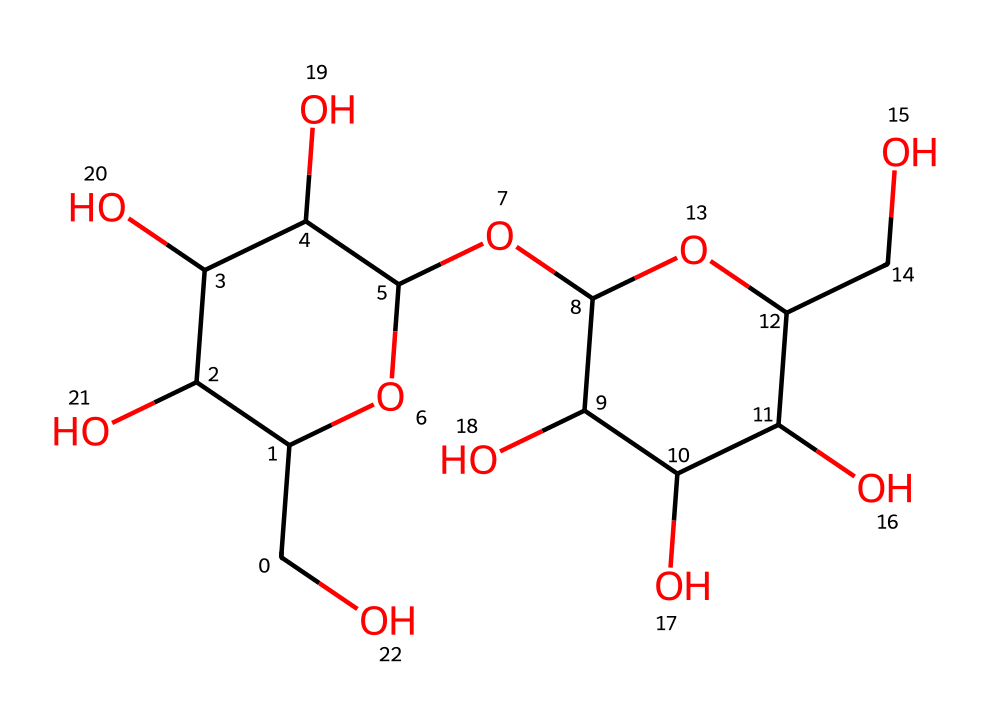what is the name of this carbohydrate? This chemical structure represents lactose, which is a disaccharide sugar composed of glucose and galactose. The specific arrangement of atoms supports this identification.
Answer: lactose how many carbon atoms are present in lactose? By counting the carbon atoms in the SMILES representation, there are 12 carbon atoms total. Each 'C' represents one carbon atom, and by visual inspection, we confirm this count.
Answer: 12 how many hydroxyl (–OH) groups are there in lactose? The structure shows that lactose has 6 hydroxyl groups. Each –OH can be seen as part of the rings and chain, represented in the SMILES notation.
Answer: 6 is lactose a reducing or non-reducing sugar? Lactose is a reducing sugar because it has a free anomeric carbon that can act as a reducing agent. This can be identified from the structure where the glucose ring is not fully closed in the disaccharide.
Answer: reducing what type of carbohydrate is lactose classified as? Lactose is classified as a disaccharide, meaning it consists of two monosaccharide units linked together. This classification is evident from its structure, which consists of two sugar units (glucose and galactose).
Answer: disaccharide what is the molecular formula for lactose? The molecular formula for lactose can be derived from the counted atoms: C12H22O11, indicating the elements present in specific quantities based on the structure.
Answer: C12H22O11 what functional groups are present in lactose? The primary functional groups in lactose are hydroxyl groups (–OH) and an ether linkage (–O–) between the two sugar units. By examining the structure, we can identify these specific groups.
Answer: hydroxyl and ether 